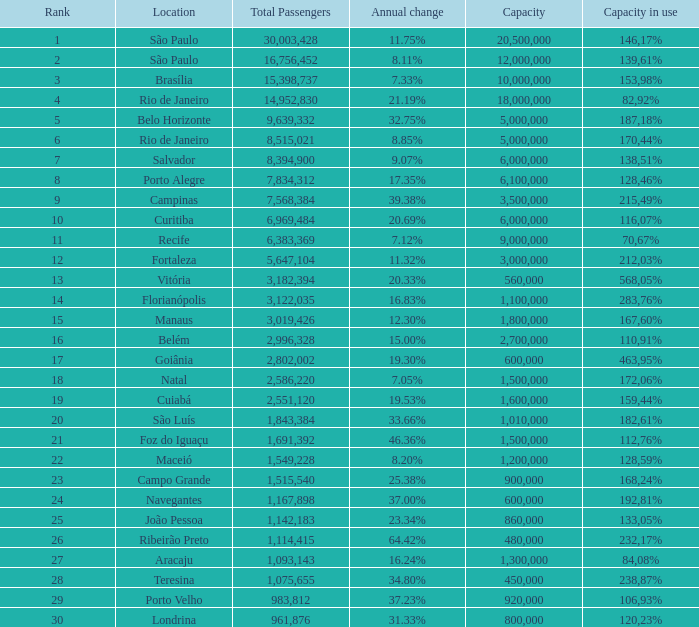Which location has a capacity that has a rank of 23? 168,24%. 